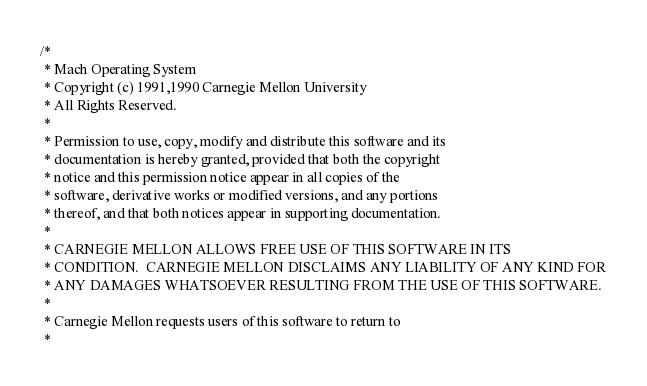<code> <loc_0><loc_0><loc_500><loc_500><_C_>/*
 * Mach Operating System
 * Copyright (c) 1991,1990 Carnegie Mellon University
 * All Rights Reserved.
 *
 * Permission to use, copy, modify and distribute this software and its
 * documentation is hereby granted, provided that both the copyright
 * notice and this permission notice appear in all copies of the
 * software, derivative works or modified versions, and any portions
 * thereof, and that both notices appear in supporting documentation.
 *
 * CARNEGIE MELLON ALLOWS FREE USE OF THIS SOFTWARE IN ITS
 * CONDITION.  CARNEGIE MELLON DISCLAIMS ANY LIABILITY OF ANY KIND FOR
 * ANY DAMAGES WHATSOEVER RESULTING FROM THE USE OF THIS SOFTWARE.
 *
 * Carnegie Mellon requests users of this software to return to
 *</code> 